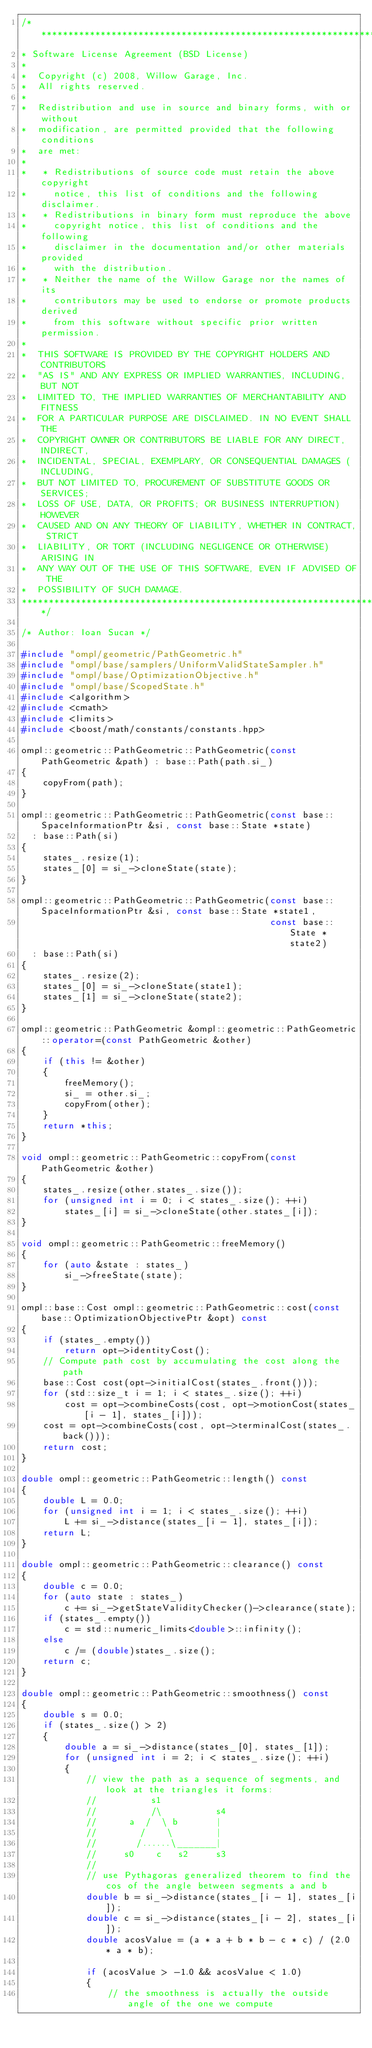Convert code to text. <code><loc_0><loc_0><loc_500><loc_500><_C++_>/*********************************************************************
* Software License Agreement (BSD License)
*
*  Copyright (c) 2008, Willow Garage, Inc.
*  All rights reserved.
*
*  Redistribution and use in source and binary forms, with or without
*  modification, are permitted provided that the following conditions
*  are met:
*
*   * Redistributions of source code must retain the above copyright
*     notice, this list of conditions and the following disclaimer.
*   * Redistributions in binary form must reproduce the above
*     copyright notice, this list of conditions and the following
*     disclaimer in the documentation and/or other materials provided
*     with the distribution.
*   * Neither the name of the Willow Garage nor the names of its
*     contributors may be used to endorse or promote products derived
*     from this software without specific prior written permission.
*
*  THIS SOFTWARE IS PROVIDED BY THE COPYRIGHT HOLDERS AND CONTRIBUTORS
*  "AS IS" AND ANY EXPRESS OR IMPLIED WARRANTIES, INCLUDING, BUT NOT
*  LIMITED TO, THE IMPLIED WARRANTIES OF MERCHANTABILITY AND FITNESS
*  FOR A PARTICULAR PURPOSE ARE DISCLAIMED. IN NO EVENT SHALL THE
*  COPYRIGHT OWNER OR CONTRIBUTORS BE LIABLE FOR ANY DIRECT, INDIRECT,
*  INCIDENTAL, SPECIAL, EXEMPLARY, OR CONSEQUENTIAL DAMAGES (INCLUDING,
*  BUT NOT LIMITED TO, PROCUREMENT OF SUBSTITUTE GOODS OR SERVICES;
*  LOSS OF USE, DATA, OR PROFITS; OR BUSINESS INTERRUPTION) HOWEVER
*  CAUSED AND ON ANY THEORY OF LIABILITY, WHETHER IN CONTRACT, STRICT
*  LIABILITY, OR TORT (INCLUDING NEGLIGENCE OR OTHERWISE) ARISING IN
*  ANY WAY OUT OF THE USE OF THIS SOFTWARE, EVEN IF ADVISED OF THE
*  POSSIBILITY OF SUCH DAMAGE.
*********************************************************************/

/* Author: Ioan Sucan */

#include "ompl/geometric/PathGeometric.h"
#include "ompl/base/samplers/UniformValidStateSampler.h"
#include "ompl/base/OptimizationObjective.h"
#include "ompl/base/ScopedState.h"
#include <algorithm>
#include <cmath>
#include <limits>
#include <boost/math/constants/constants.hpp>

ompl::geometric::PathGeometric::PathGeometric(const PathGeometric &path) : base::Path(path.si_)
{
    copyFrom(path);
}

ompl::geometric::PathGeometric::PathGeometric(const base::SpaceInformationPtr &si, const base::State *state)
  : base::Path(si)
{
    states_.resize(1);
    states_[0] = si_->cloneState(state);
}

ompl::geometric::PathGeometric::PathGeometric(const base::SpaceInformationPtr &si, const base::State *state1,
                                              const base::State *state2)
  : base::Path(si)
{
    states_.resize(2);
    states_[0] = si_->cloneState(state1);
    states_[1] = si_->cloneState(state2);
}

ompl::geometric::PathGeometric &ompl::geometric::PathGeometric::operator=(const PathGeometric &other)
{
    if (this != &other)
    {
        freeMemory();
        si_ = other.si_;
        copyFrom(other);
    }
    return *this;
}

void ompl::geometric::PathGeometric::copyFrom(const PathGeometric &other)
{
    states_.resize(other.states_.size());
    for (unsigned int i = 0; i < states_.size(); ++i)
        states_[i] = si_->cloneState(other.states_[i]);
}

void ompl::geometric::PathGeometric::freeMemory()
{
    for (auto &state : states_)
        si_->freeState(state);
}

ompl::base::Cost ompl::geometric::PathGeometric::cost(const base::OptimizationObjectivePtr &opt) const
{
    if (states_.empty())
        return opt->identityCost();
    // Compute path cost by accumulating the cost along the path
    base::Cost cost(opt->initialCost(states_.front()));
    for (std::size_t i = 1; i < states_.size(); ++i)
        cost = opt->combineCosts(cost, opt->motionCost(states_[i - 1], states_[i]));
    cost = opt->combineCosts(cost, opt->terminalCost(states_.back()));
    return cost;
}

double ompl::geometric::PathGeometric::length() const
{
    double L = 0.0;
    for (unsigned int i = 1; i < states_.size(); ++i)
        L += si_->distance(states_[i - 1], states_[i]);
    return L;
}

double ompl::geometric::PathGeometric::clearance() const
{
    double c = 0.0;
    for (auto state : states_)
        c += si_->getStateValidityChecker()->clearance(state);
    if (states_.empty())
        c = std::numeric_limits<double>::infinity();
    else
        c /= (double)states_.size();
    return c;
}

double ompl::geometric::PathGeometric::smoothness() const
{
    double s = 0.0;
    if (states_.size() > 2)
    {
        double a = si_->distance(states_[0], states_[1]);
        for (unsigned int i = 2; i < states_.size(); ++i)
        {
            // view the path as a sequence of segments, and look at the triangles it forms:
            //          s1
            //          /\          s4
            //      a  /  \ b       |
            //        /    \        |
            //       /......\_______|
            //     s0    c   s2     s3
            //
            // use Pythagoras generalized theorem to find the cos of the angle between segments a and b
            double b = si_->distance(states_[i - 1], states_[i]);
            double c = si_->distance(states_[i - 2], states_[i]);
            double acosValue = (a * a + b * b - c * c) / (2.0 * a * b);

            if (acosValue > -1.0 && acosValue < 1.0)
            {
                // the smoothness is actually the outside angle of the one we compute</code> 